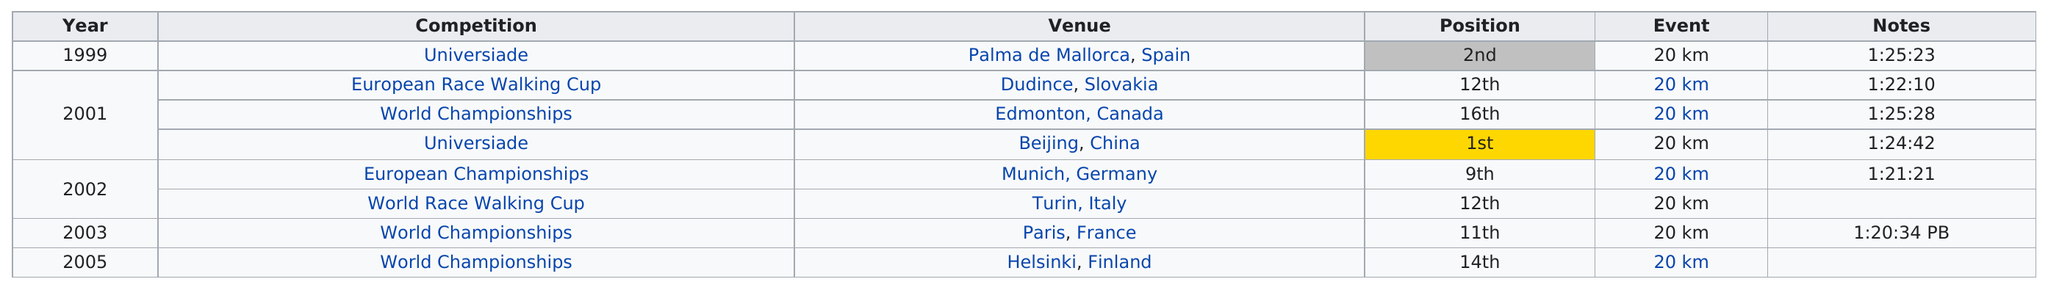Point out several critical features in this image. In the years 1999, 2003, and 2005, Civilero achieved only one achievement. The total number of times that the competition is listed as "world championships" is 3. The World Championships had the least amount of time. In 2001, Lorenzo took first place. Civilero's first listed achievement was in 1999. 